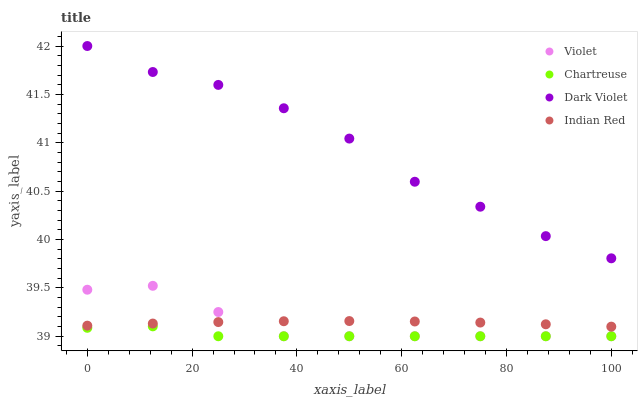Does Chartreuse have the minimum area under the curve?
Answer yes or no. Yes. Does Dark Violet have the maximum area under the curve?
Answer yes or no. Yes. Does Indian Red have the minimum area under the curve?
Answer yes or no. No. Does Indian Red have the maximum area under the curve?
Answer yes or no. No. Is Indian Red the smoothest?
Answer yes or no. Yes. Is Dark Violet the roughest?
Answer yes or no. Yes. Is Dark Violet the smoothest?
Answer yes or no. No. Is Indian Red the roughest?
Answer yes or no. No. Does Chartreuse have the lowest value?
Answer yes or no. Yes. Does Indian Red have the lowest value?
Answer yes or no. No. Does Dark Violet have the highest value?
Answer yes or no. Yes. Does Indian Red have the highest value?
Answer yes or no. No. Is Violet less than Dark Violet?
Answer yes or no. Yes. Is Indian Red greater than Chartreuse?
Answer yes or no. Yes. Does Violet intersect Indian Red?
Answer yes or no. Yes. Is Violet less than Indian Red?
Answer yes or no. No. Is Violet greater than Indian Red?
Answer yes or no. No. Does Violet intersect Dark Violet?
Answer yes or no. No. 